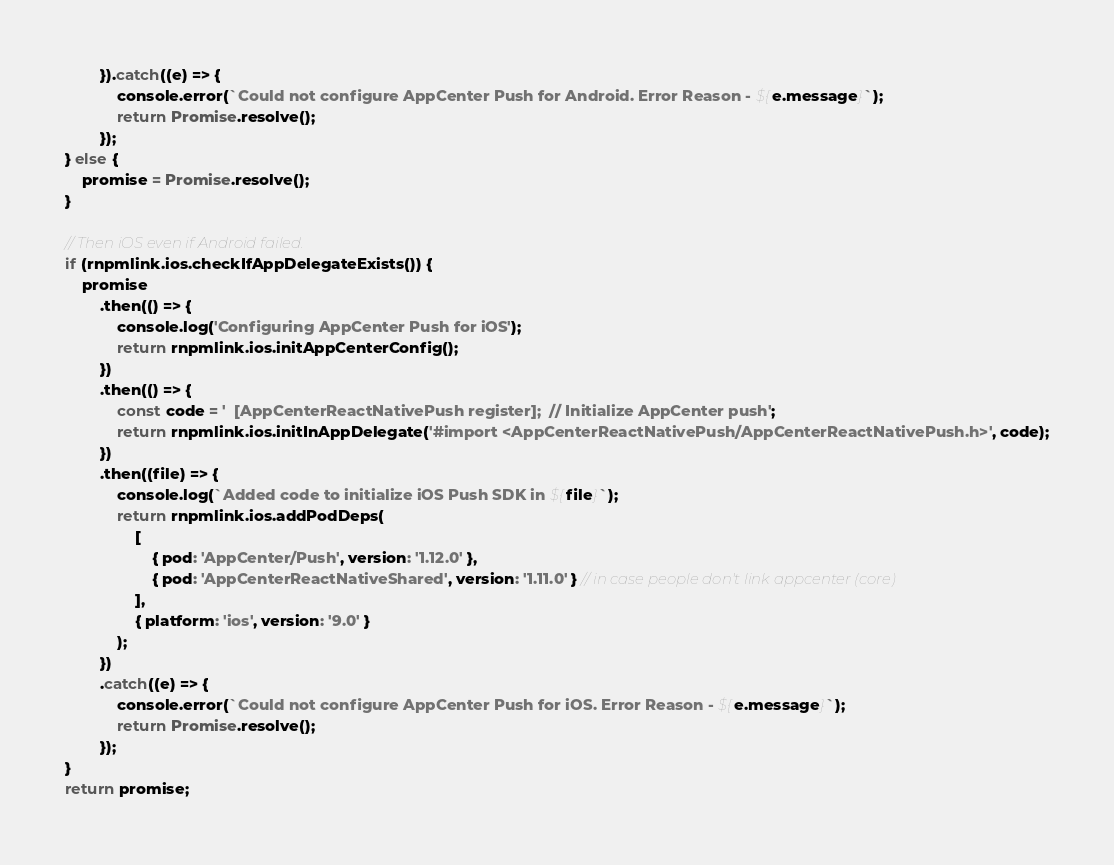Convert code to text. <code><loc_0><loc_0><loc_500><loc_500><_JavaScript_>        }).catch((e) => {
            console.error(`Could not configure AppCenter Push for Android. Error Reason - ${e.message}`);
            return Promise.resolve();
        });
} else {
    promise = Promise.resolve();
}

// Then iOS even if Android failed.
if (rnpmlink.ios.checkIfAppDelegateExists()) {
    promise
        .then(() => {
            console.log('Configuring AppCenter Push for iOS');
            return rnpmlink.ios.initAppCenterConfig();
        })
        .then(() => {
            const code = '  [AppCenterReactNativePush register];  // Initialize AppCenter push';
            return rnpmlink.ios.initInAppDelegate('#import <AppCenterReactNativePush/AppCenterReactNativePush.h>', code);
        })
        .then((file) => {
            console.log(`Added code to initialize iOS Push SDK in ${file}`);
            return rnpmlink.ios.addPodDeps(
                [
                    { pod: 'AppCenter/Push', version: '1.12.0' },
                    { pod: 'AppCenterReactNativeShared', version: '1.11.0' } // in case people don't link appcenter (core)
                ],
                { platform: 'ios', version: '9.0' }
            );
        })
        .catch((e) => {
            console.error(`Could not configure AppCenter Push for iOS. Error Reason - ${e.message}`);
            return Promise.resolve();
        });
}
return promise;
</code> 